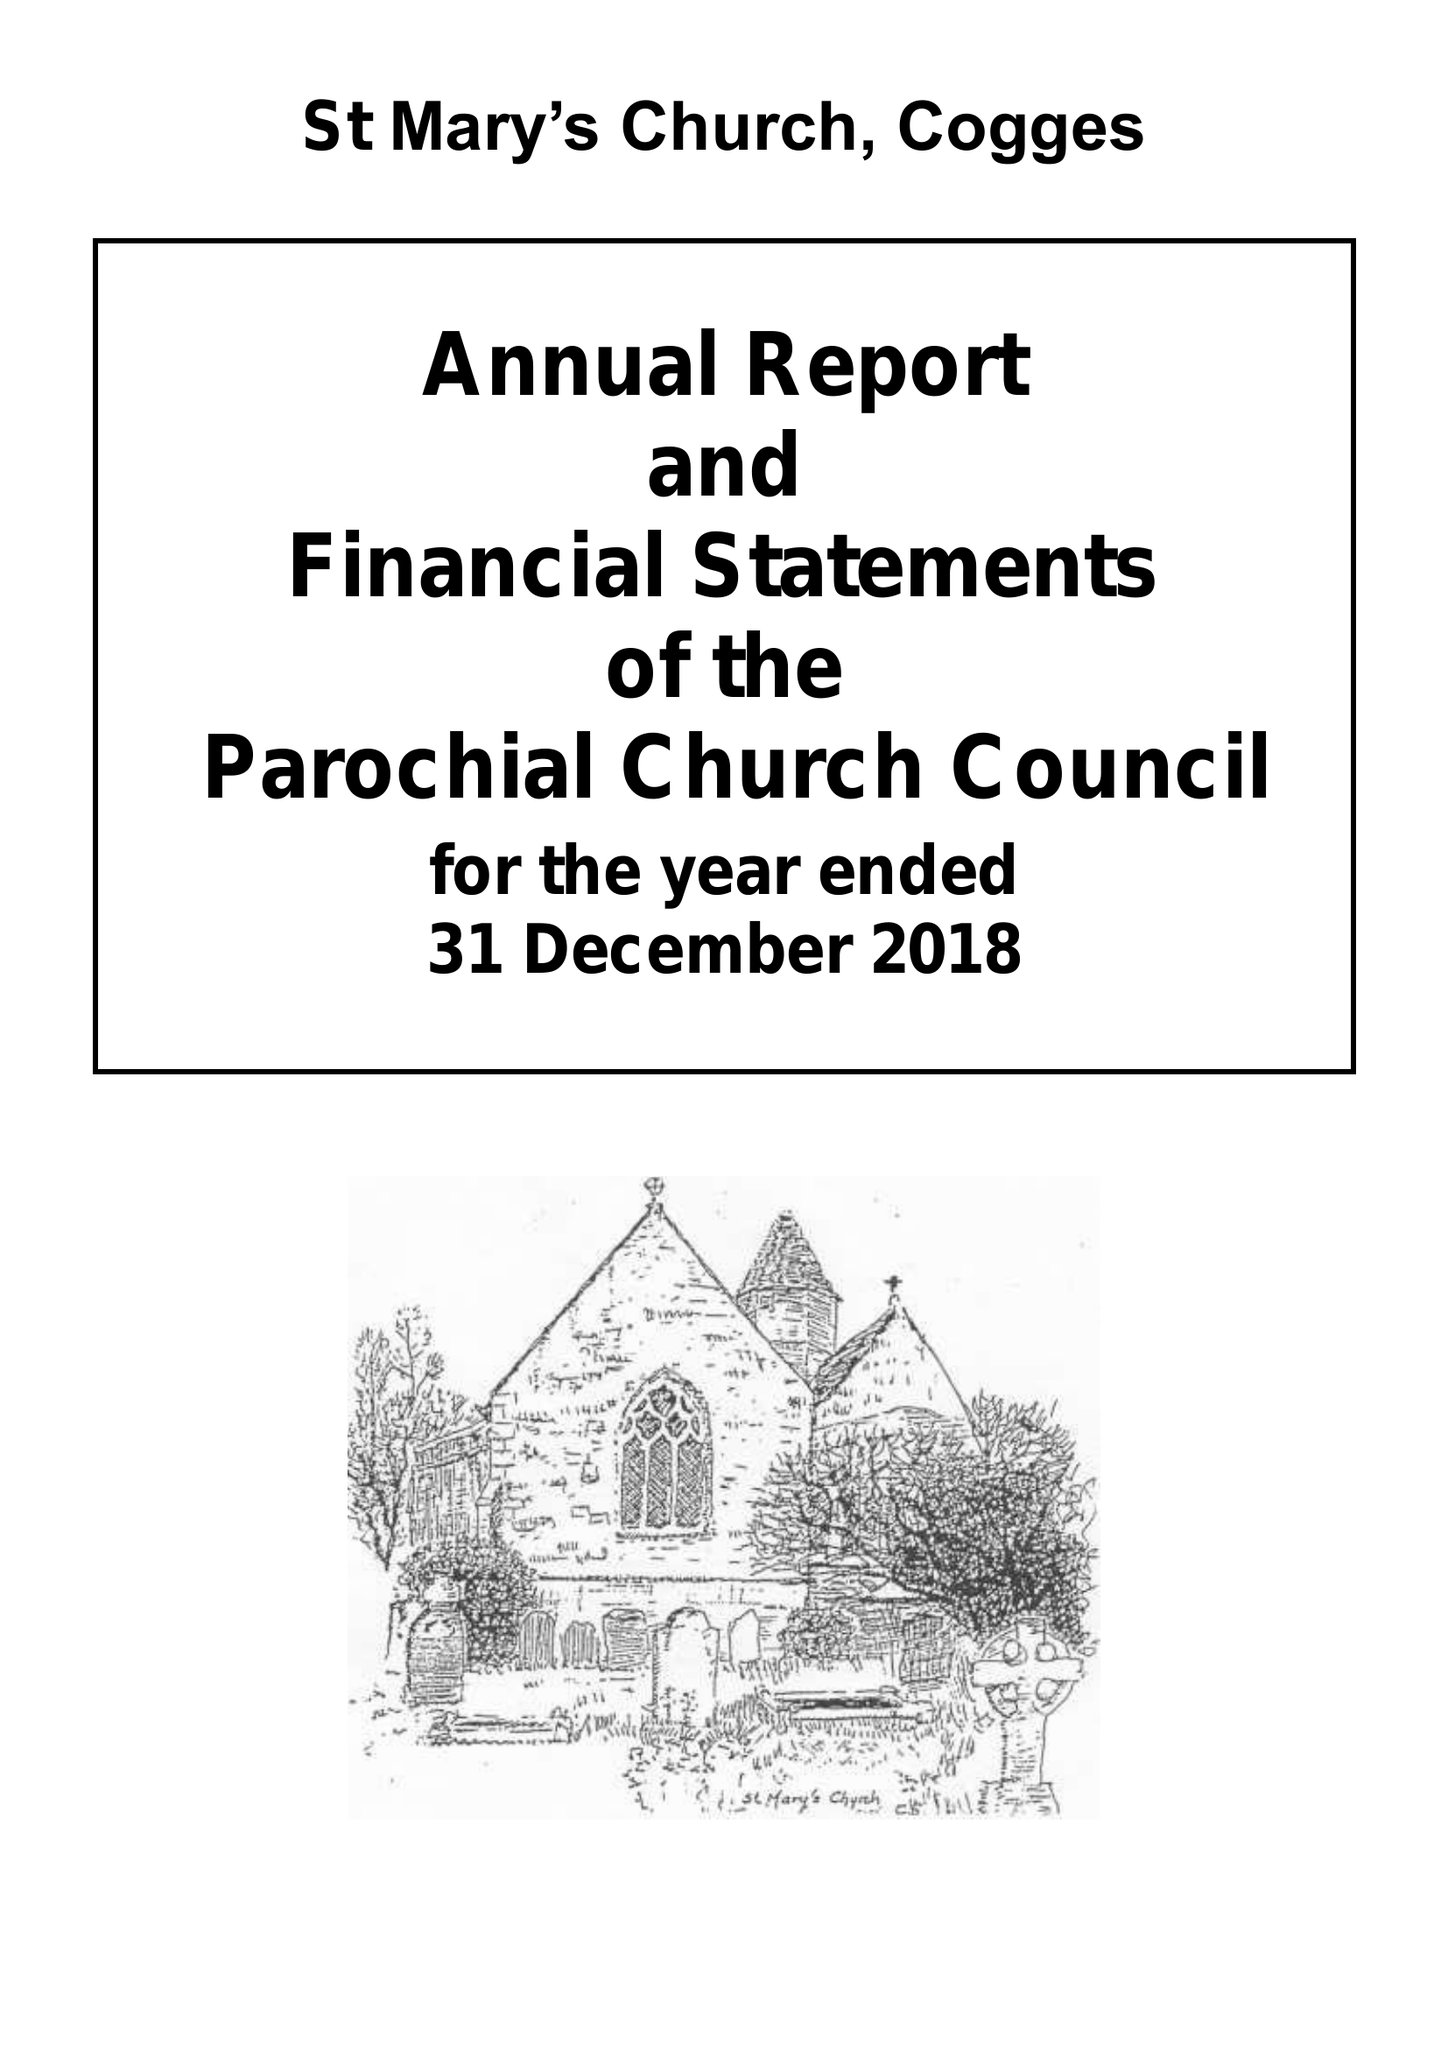What is the value for the spending_annually_in_british_pounds?
Answer the question using a single word or phrase. 316393.89 